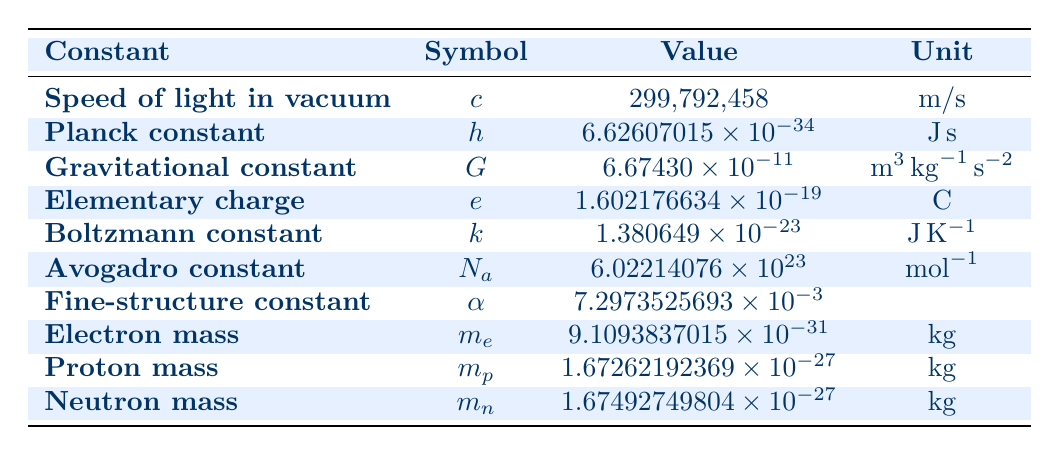What is the value of the speed of light in vacuum? The speed of light in vacuum is listed in the table under the 'Value' column next to 'Speed of light in vacuum.' That value is 299,792,458.
Answer: 299,792,458 What is the unit for the Planck constant? The unit for the Planck constant is provided in the 'Unit' column next to 'Planck constant.' It is expressed as J.s, which stands for joules times seconds.
Answer: J.s Is the gravitational constant greater than the elementary charge? To determine this, we compare the values from the table. The gravitational constant is 6.67430 × 10⁻¹¹ and the elementary charge is 1.602176634 × 10⁻¹⁹. Since 6.67430 × 10⁻¹¹ is greater than 1.602176634 × 10⁻¹⁹, the statement is true.
Answer: Yes What is the total mass of the electron, proton, and neutron? The masses of the electron, proton, and neutron are given in the table as follows: electron mass is 9.1093837015 × 10⁻³¹ kg, proton mass is 1.67262192369 × 10⁻²⁷ kg, and neutron mass is 1.67492749804 × 10⁻²⁷ kg. To find the total mass, we convert the units for consistency if needed (but they are already in kg) and sum them: 
Total mass = (9.1093837015 × 10⁻³¹) + (1.67262192369 × 10⁻²⁷) + (1.67492749804 × 10⁻²⁷) = (9.1093837015 × 10⁻³¹ + 0.000000000000167262192369 + 0.000000000000167492749804) kg = approximately 1.67492749804 × 10⁻²⁷ kg.
Answer: 1.67492749804 × 10⁻²⁷ kg What is the value of the fine-structure constant? The fine-structure constant is listed next to its symbol in the table under the 'Value' column. The value is 7.2973525693 × 10⁻³.
Answer: 7.2973525693 × 10⁻³ How does the value of the Avogadro constant compare to that of the Boltzmann constant? The Avogadro constant is listed as 6.02214076 × 10²³, while the Boltzmann constant is 1.380649 × 10⁻²³. To compare, we notice that 6.02214076 × 10²³ is significantly larger than 1.380649 × 10⁻²³, indicating that Avogadro constant has a higher value.
Answer: Avogadro constant is greater 